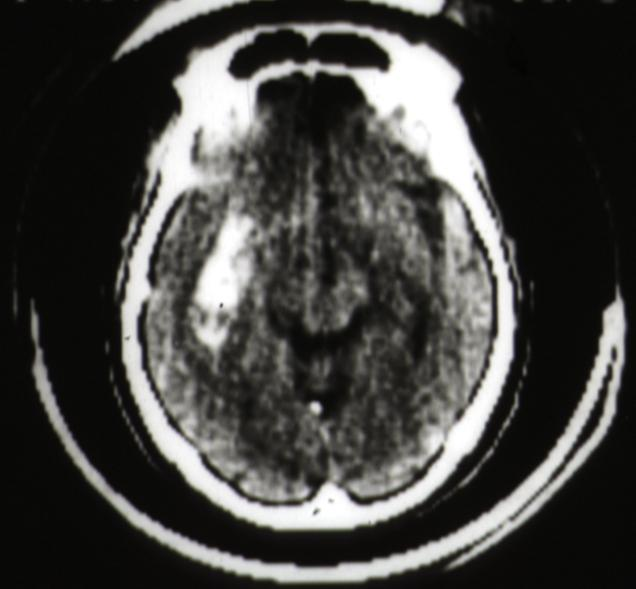s brain present?
Answer the question using a single word or phrase. Yes 